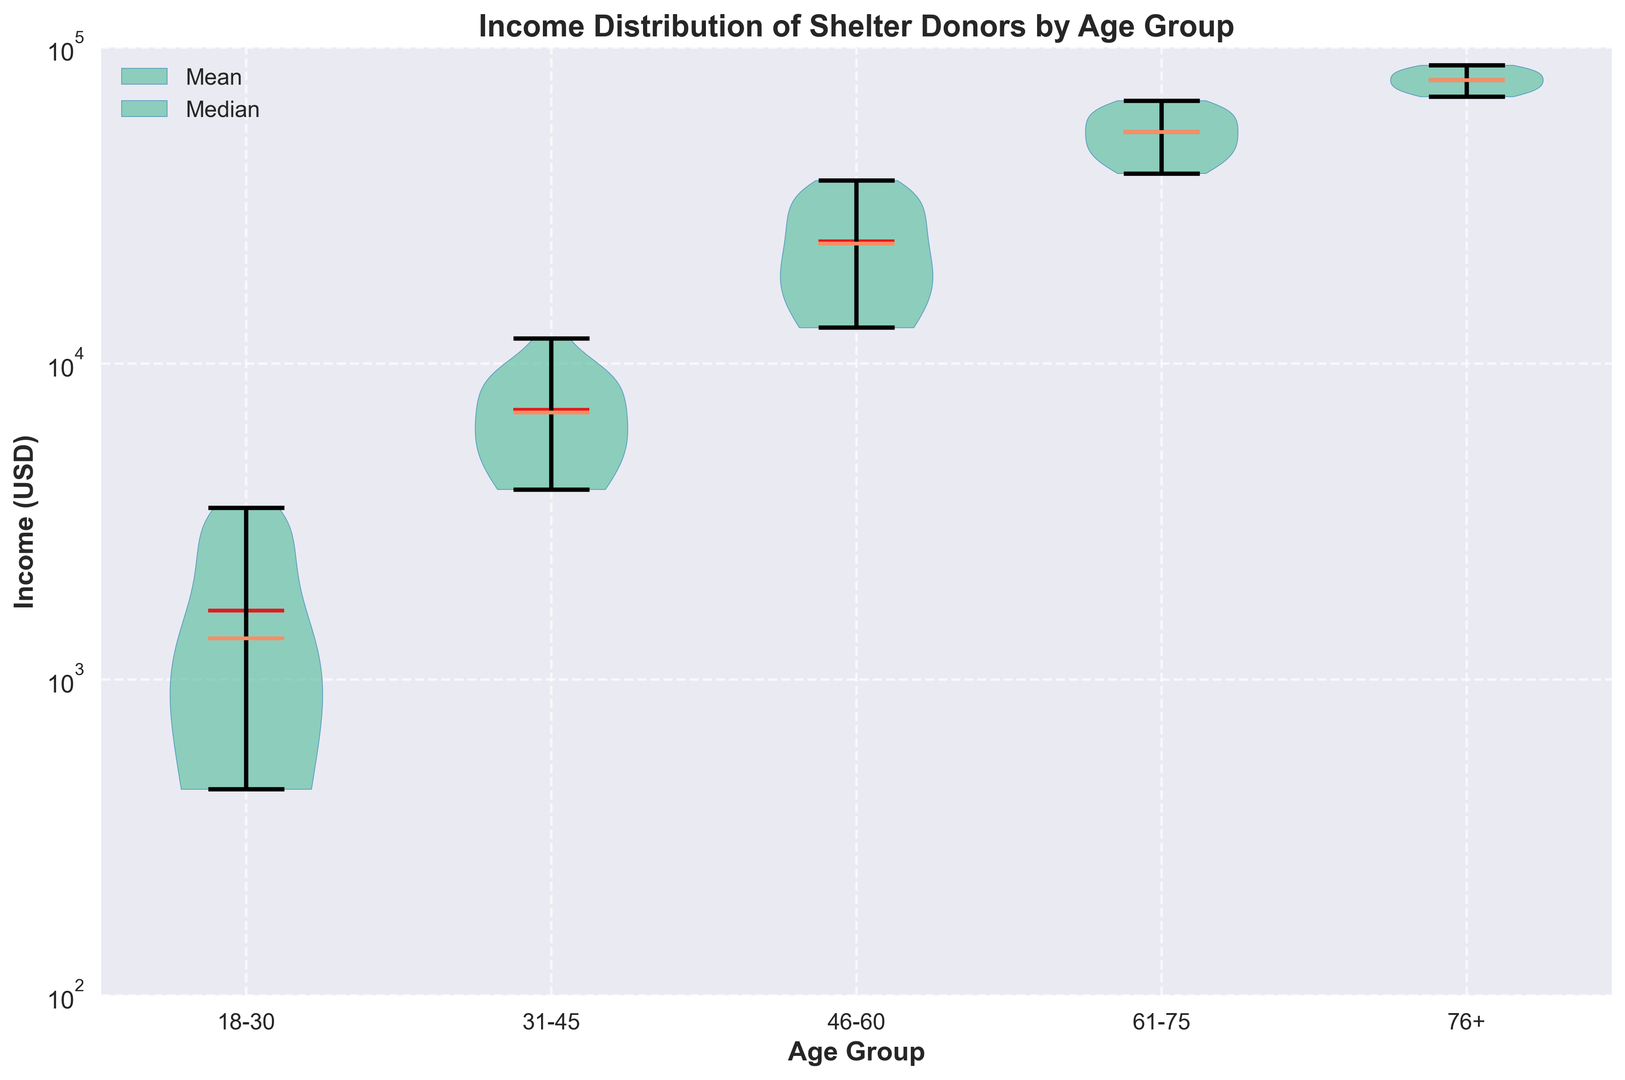which age group has the highest median income? The median income is indicated by the orange line in the violin plots. The age group '76+' has the highest median income as its orange line is the highest among all age groups.
Answer: 76+ which age group has the lowest median income? The median income is indicated by the orange line in the violin plots. The age group '18-30' has the lowest median income as its orange line is the lowest among all age groups.
Answer: 18-30 which age group shows the widest income distribution? The width of the violin plot indicates the income distribution's density. The age group '46-60' shows the widest distribution as its violin plot is the broadest, indicating a wide spread of incomes within this age group.
Answer: 46-60 what is the mean income for the age group '61-75'? The mean income is indicated by the red line in the violin plots. For the age group '61-75', the red line is located between $40,000 and $50,000.
Answer: between $40,000 and $50,000 is the median income of the '31-45' age group greater than the mean income of the '18-30' age group? The median income of '31-45' (orange line) appears to be below the mean income of '18-30' (red line) in the violin plots. So, it is not greater.
Answer: no which age group has the smallest range in its income distribution? The range is indicated by the spread from the lowest to the highest point in the violin plot. The age group '31-45' has the smallest range as its plot is the shortest from top to bottom, suggesting the least spread in incomes.
Answer: 31-45 compare the mean incomes between the '46-60' and '61-75' age groups The mean incomes are indicated by the red lines. The red line for '46-60' is lower compared to '61-75', indicating that '46-60' has a lower mean income.
Answer: 61-75 has higher mean how does the income distribution for the '76+' age group visually differ from the '18-30' age group? The '76+' age group has a much more extended and broader violin plot compared to the '18-30', indicating a wider and higher income distribution, while '18-30' is shorter and narrower.
Answer: '76+' is wider and higher which age group's income distribution shows the highest density around its mean income? The density around the mean income is shown by the width around the red line. The '46-60' age group has the highest density around its mean, indicating many donors have incomes close to the mean.
Answer: 46-60 